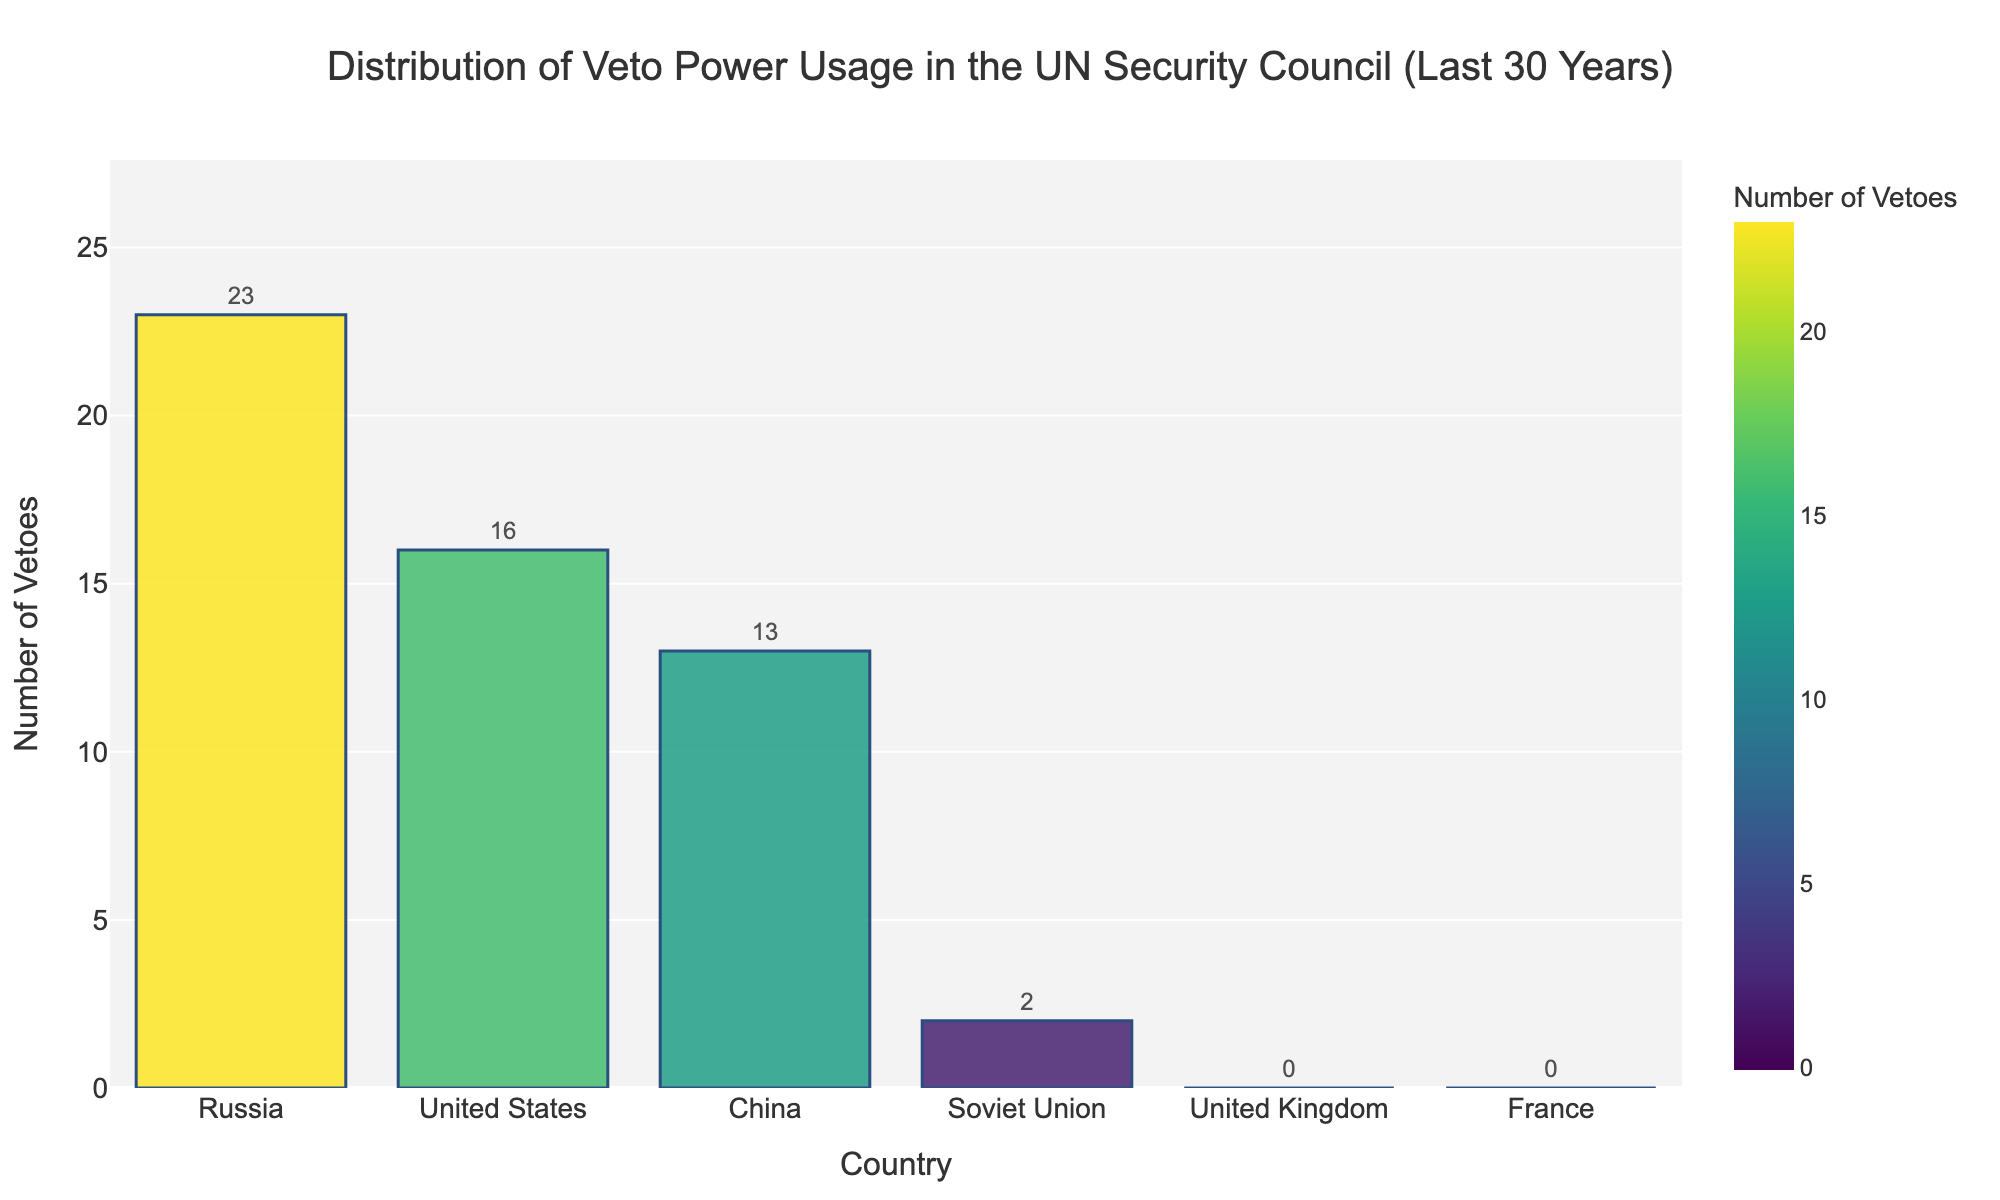What are the two countries with the highest number of vetoes? The bar chart shows the number of vetoes each permanent member of the UN Security Council has used. By visually comparing the heights of the bars, it is clear that Russia (23 vetoes) and the United States (16 vetoes) have the highest numbers.
Answer: Russia and the United States What is the combined total number of vetoes used by China and the United States? The chart indicates that China has 13 vetoes and the United States has 16 vetoes. Adding these together gives 13 + 16 = 29 vetoes.
Answer: 29 How many vetoes have been used by all countries combined? By summing the veto counts for each country: United States (16) + Russia (23) + China (13) + United Kingdom (0) + France (0) + Soviet Union (2), we get 16 + 23 + 13 + 0 + 0 + 2 = 54 vetoes.
Answer: 54 Which countries have not used their veto power in the last 30 years? The chart shows that the bars for both the United Kingdom and France are at zero height, indicating they have not used their veto power.
Answer: United Kingdom and France What is the difference in the number of vetoes used by Russia and China? By subtracting China’s veto count (13) from Russia's veto count (23), the difference is 23 - 13 = 10 vetoes.
Answer: 10 What is the average number of vetoes used by the permanent members of the UN Security Council (excluding Soviet Union)? Summing the vetoes of the permanent members (United States 16, Russia 23, China 13, United Kingdom 0, France 0) gives 16 + 23 + 13 + 0 + 0 = 52. Dividing by 5 (number of permanent members) gives 52 / 5 = 10.4 vetoes.
Answer: 10.4 What percentage of the total vetoes is attributed to the Soviet Union? With the total vetoes being 54, the percentage for the Soviet Union (2 vetoes) is calculated as (2 / 54) * 100 ≈ 3.70%.
Answer: 3.70% Among the countries listed, which one has the lowest number of vetoes used? The chart shows that both the United Kingdom and France have 0 vetoes, which is the lowest count.
Answer: United Kingdom and France Which country's bar is closest in height to the average number of vetoes used by all countries combined? First, calculate the average number of vetoes as 54 / 6 = 9. Comparing this to the veto counts: United States (16), Russia (23), China (13), United Kingdom (0), France (0), and Soviet Union (2), China's bar height of 13 is closest to the average of 9.
Answer: China 